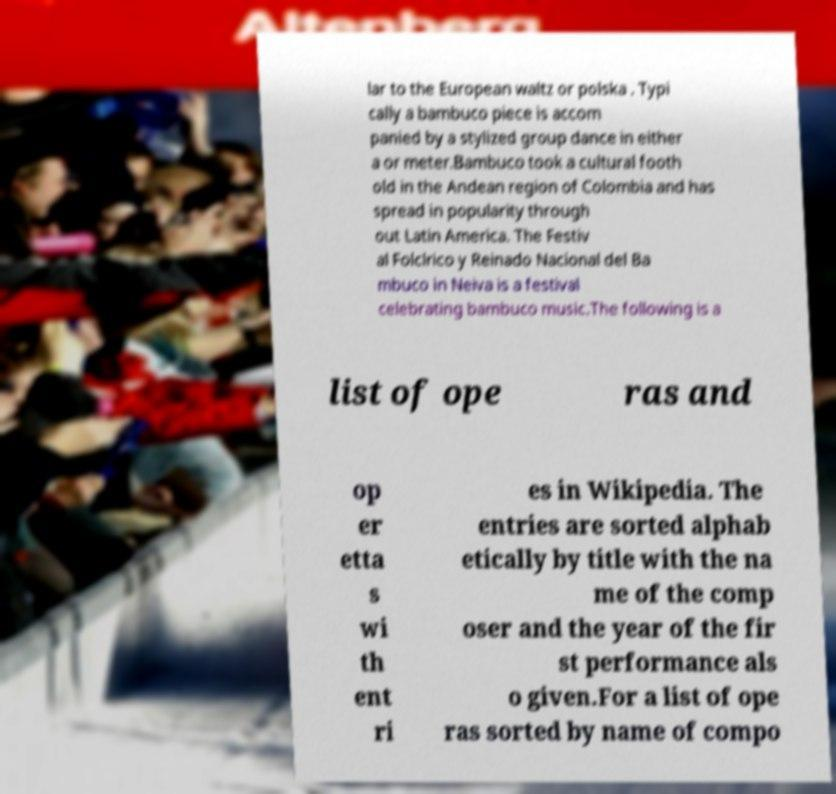Can you accurately transcribe the text from the provided image for me? lar to the European waltz or polska . Typi cally a bambuco piece is accom panied by a stylized group dance in either a or meter.Bambuco took a cultural footh old in the Andean region of Colombia and has spread in popularity through out Latin America. The Festiv al Folclrico y Reinado Nacional del Ba mbuco in Neiva is a festival celebrating bambuco music.The following is a list of ope ras and op er etta s wi th ent ri es in Wikipedia. The entries are sorted alphab etically by title with the na me of the comp oser and the year of the fir st performance als o given.For a list of ope ras sorted by name of compo 